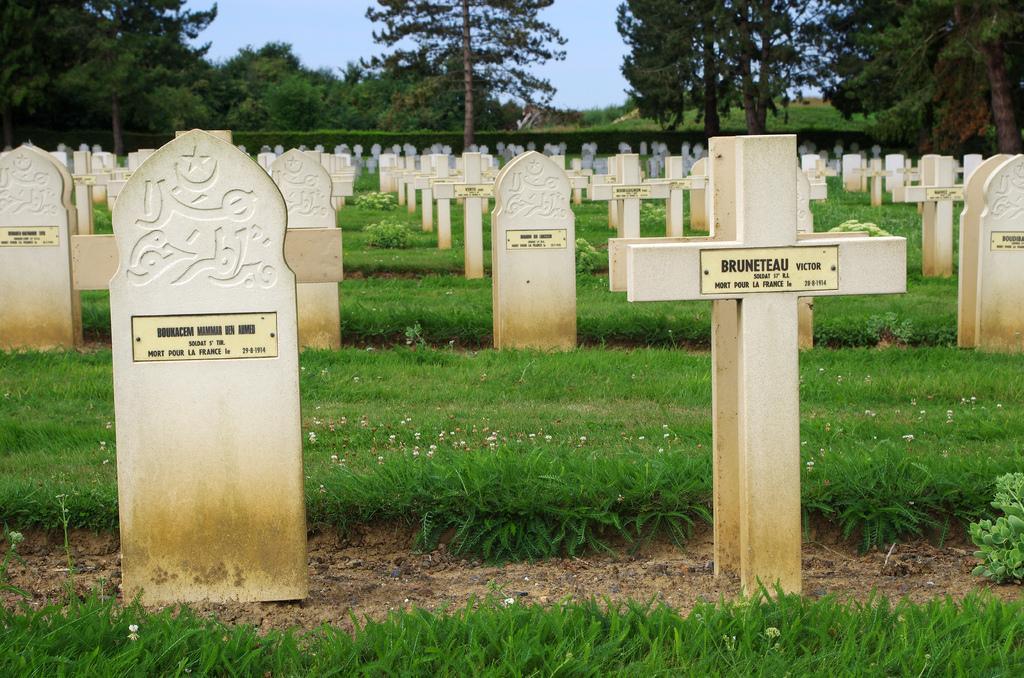Could you give a brief overview of what you see in this image? In the foreground of this image, there are headstones on the ground and we can also see grass. In the background, there are trees and the sky. 